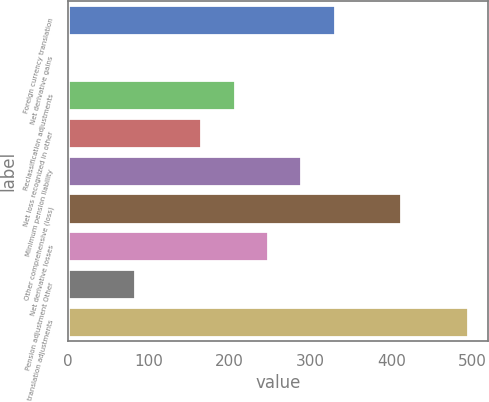Convert chart to OTSL. <chart><loc_0><loc_0><loc_500><loc_500><bar_chart><fcel>Foreign currency translation<fcel>Net derivative gains<fcel>Reclassification adjustments<fcel>Net loss recognized in other<fcel>Minimum pension liability<fcel>Other comprehensive (loss)<fcel>Net derivative losses<fcel>Pension adjustment Other<fcel>translation adjustments<nl><fcel>329.78<fcel>0.1<fcel>206.15<fcel>164.94<fcel>288.57<fcel>412.2<fcel>247.36<fcel>82.52<fcel>494.62<nl></chart> 